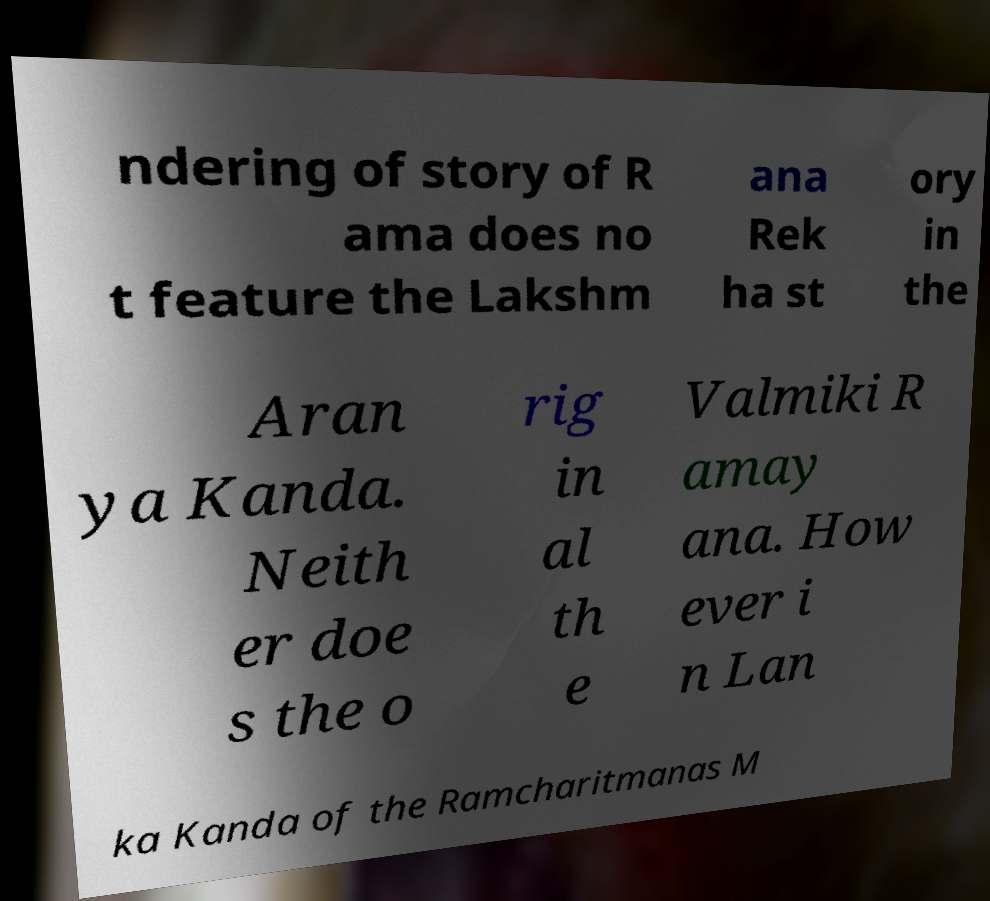Can you accurately transcribe the text from the provided image for me? ndering of story of R ama does no t feature the Lakshm ana Rek ha st ory in the Aran ya Kanda. Neith er doe s the o rig in al th e Valmiki R amay ana. How ever i n Lan ka Kanda of the Ramcharitmanas M 